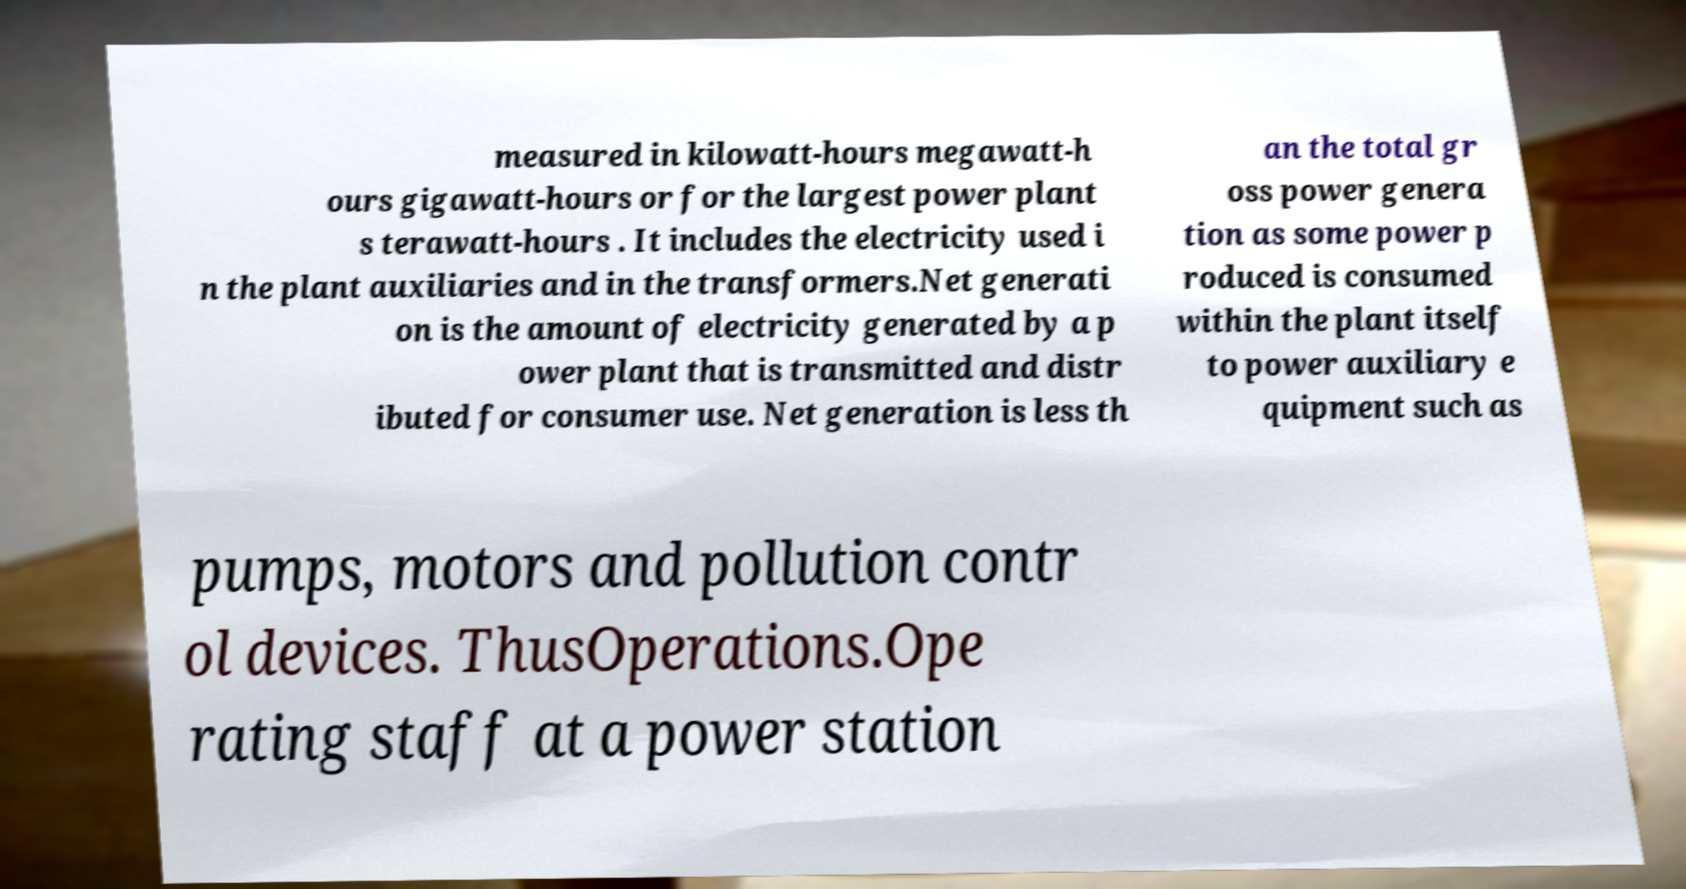What messages or text are displayed in this image? I need them in a readable, typed format. measured in kilowatt-hours megawatt-h ours gigawatt-hours or for the largest power plant s terawatt-hours . It includes the electricity used i n the plant auxiliaries and in the transformers.Net generati on is the amount of electricity generated by a p ower plant that is transmitted and distr ibuted for consumer use. Net generation is less th an the total gr oss power genera tion as some power p roduced is consumed within the plant itself to power auxiliary e quipment such as pumps, motors and pollution contr ol devices. ThusOperations.Ope rating staff at a power station 